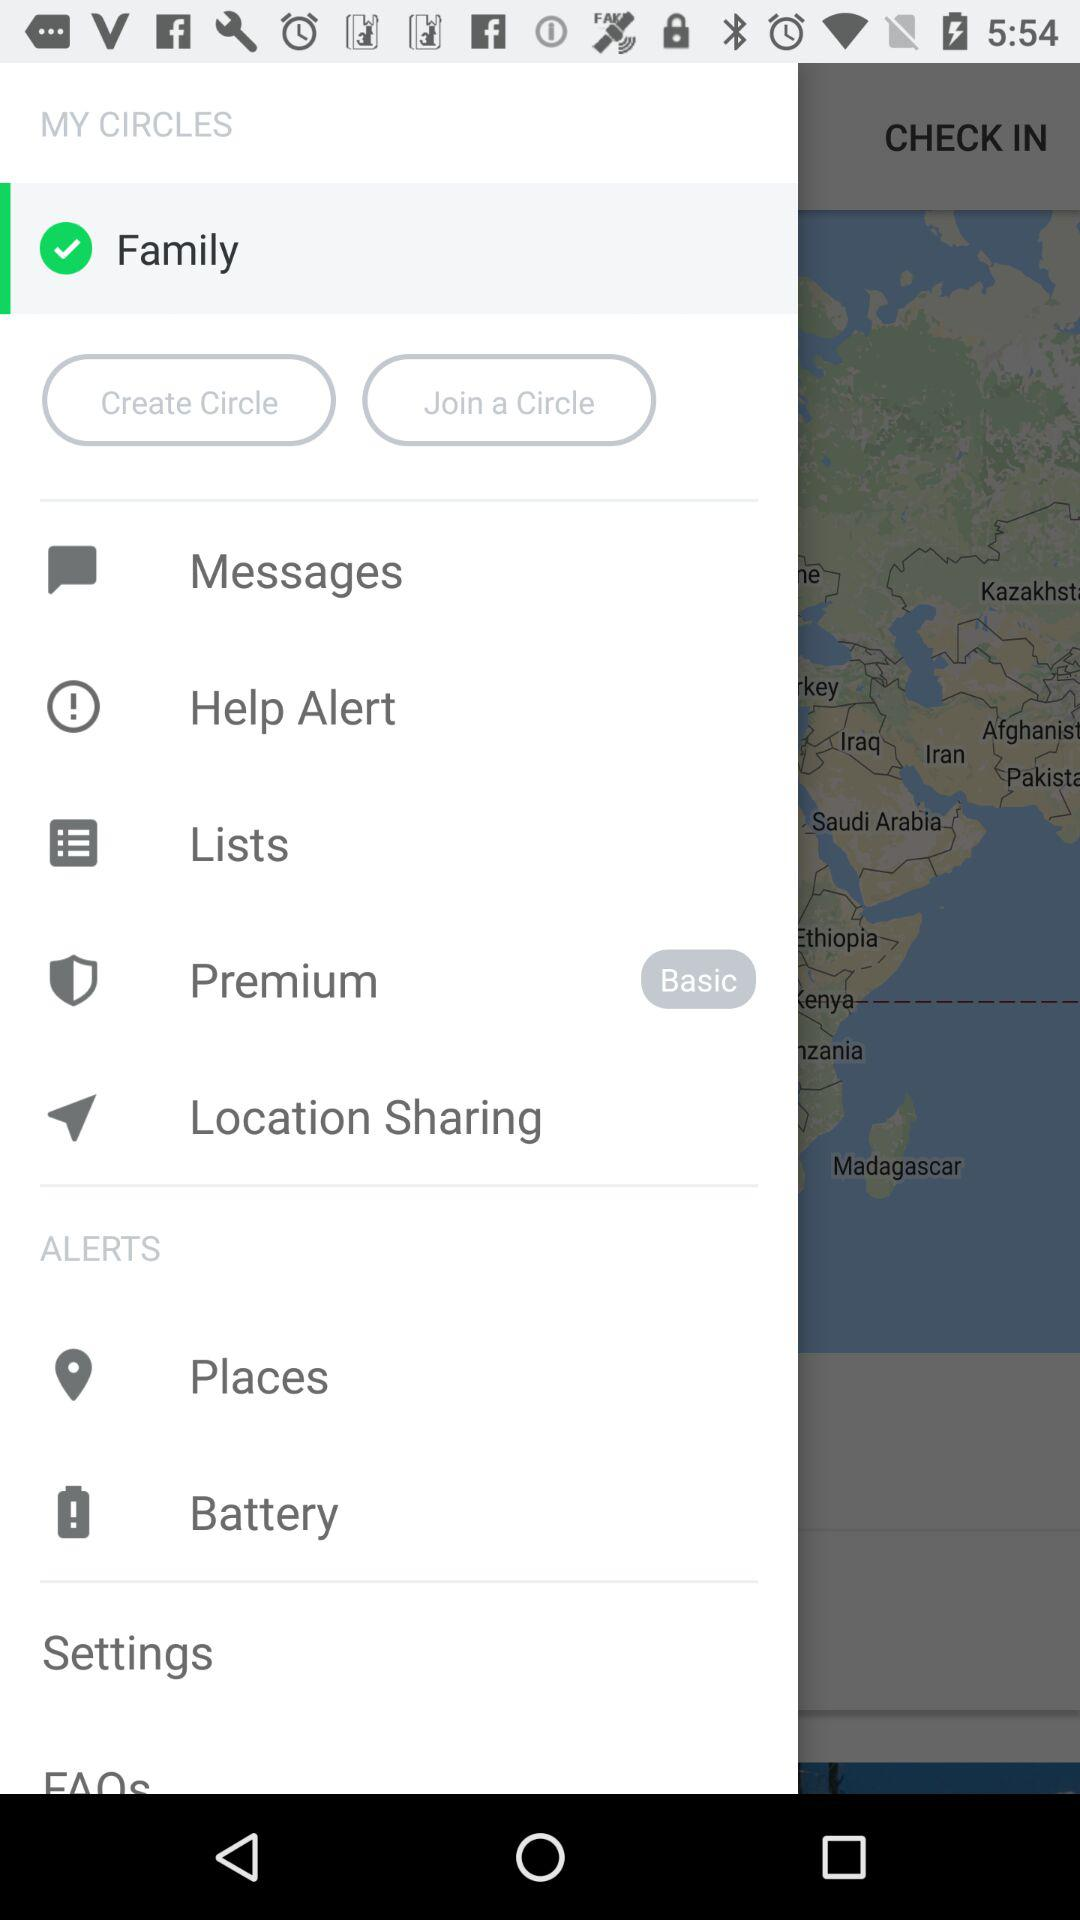What is the selected item in the menu? The selected item in the menu is "Family". 